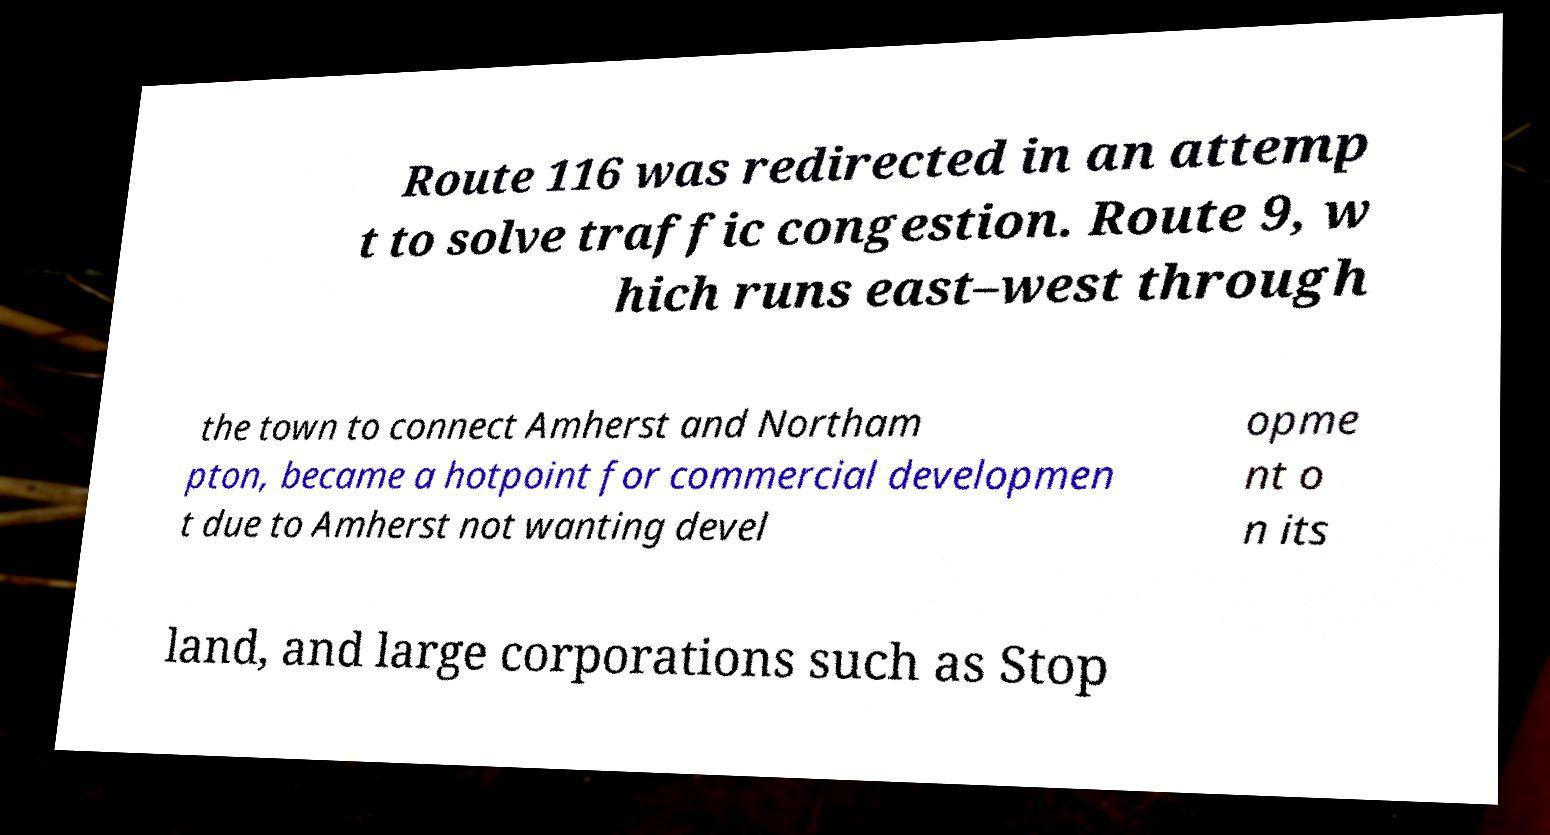Please read and relay the text visible in this image. What does it say? Route 116 was redirected in an attemp t to solve traffic congestion. Route 9, w hich runs east–west through the town to connect Amherst and Northam pton, became a hotpoint for commercial developmen t due to Amherst not wanting devel opme nt o n its land, and large corporations such as Stop 